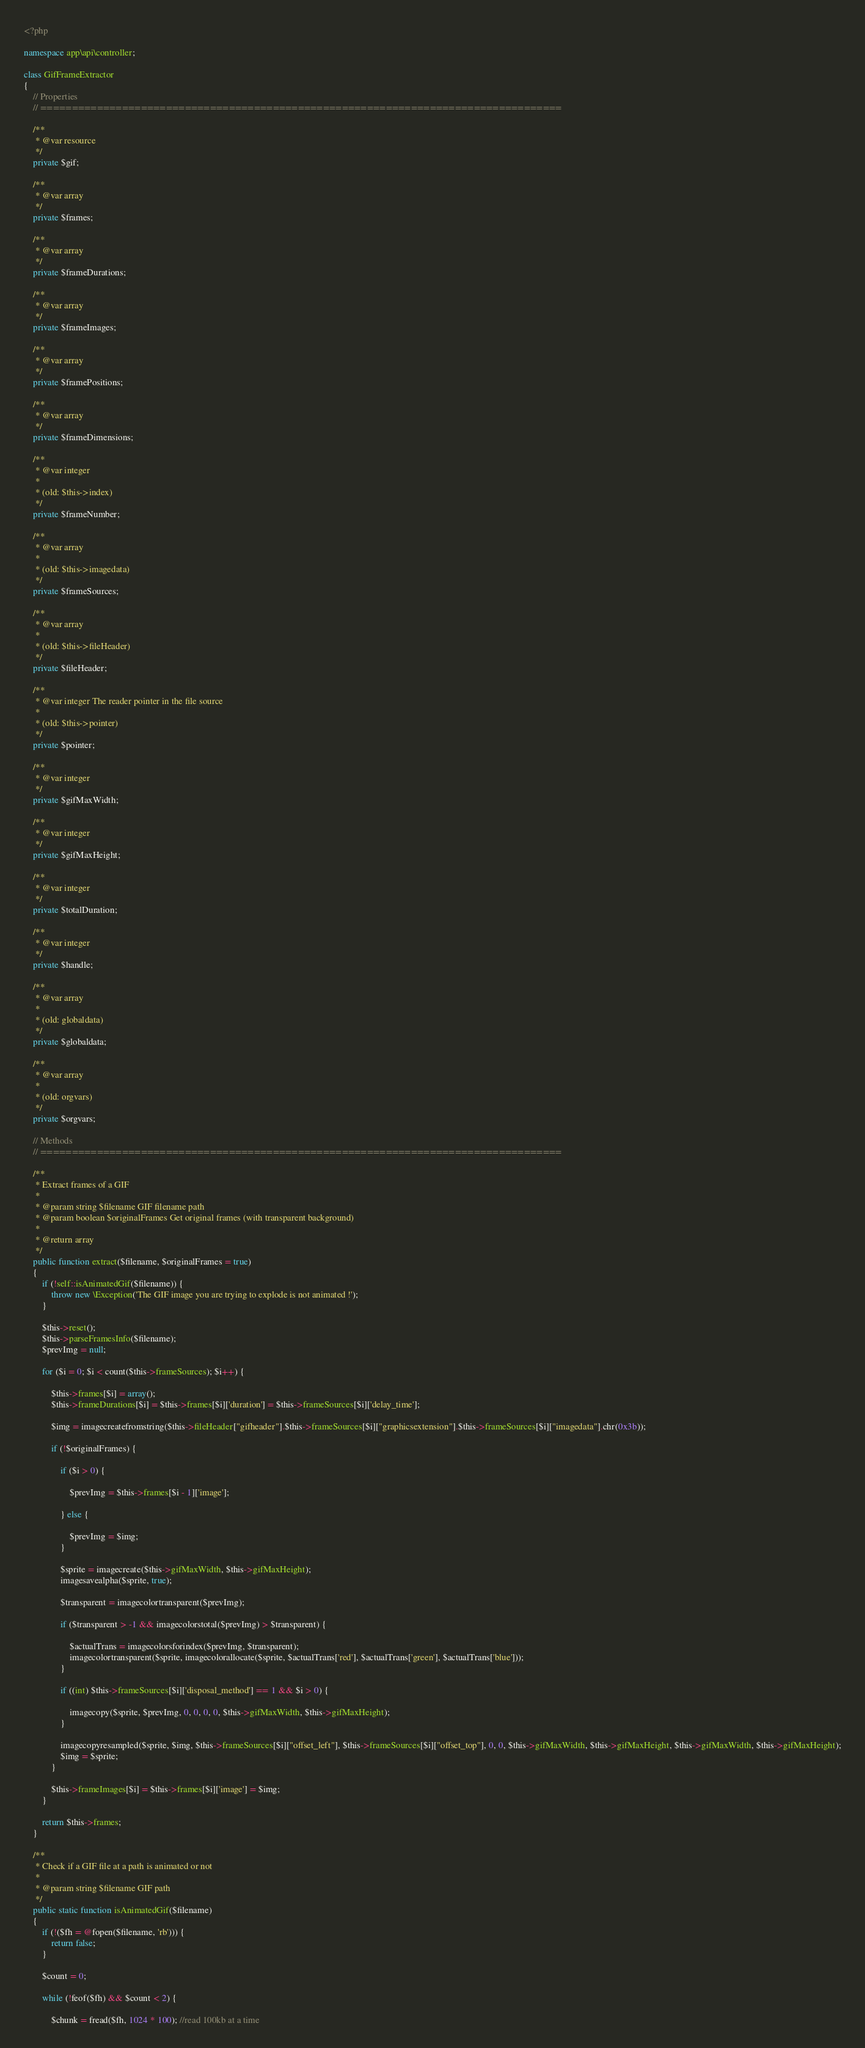<code> <loc_0><loc_0><loc_500><loc_500><_PHP_><?php

namespace app\api\controller;

class GifFrameExtractor
{
    // Properties
    // ===================================================================================

    /**
     * @var resource
     */
    private $gif;

    /**
     * @var array
     */
    private $frames;

    /**
     * @var array
     */
    private $frameDurations;

    /**
     * @var array
     */
    private $frameImages;

    /**
     * @var array
     */
    private $framePositions;

    /**
     * @var array
     */
    private $frameDimensions;

    /**
     * @var integer
     *
     * (old: $this->index)
     */
    private $frameNumber;

    /**
     * @var array
     *
     * (old: $this->imagedata)
     */
    private $frameSources;

    /**
     * @var array
     *
     * (old: $this->fileHeader)
     */
    private $fileHeader;

    /**
     * @var integer The reader pointer in the file source
     *
     * (old: $this->pointer)
     */
    private $pointer;

    /**
     * @var integer
     */
    private $gifMaxWidth;

    /**
     * @var integer
     */
    private $gifMaxHeight;

    /**
     * @var integer
     */
    private $totalDuration;

    /**
     * @var integer
     */
    private $handle;

    /**
     * @var array
     *
     * (old: globaldata)
     */
    private $globaldata;

    /**
     * @var array
     *
     * (old: orgvars)
     */
    private $orgvars;

    // Methods
    // ===================================================================================

    /**
     * Extract frames of a GIF
     *
     * @param string $filename GIF filename path
     * @param boolean $originalFrames Get original frames (with transparent background)
     *
     * @return array
     */
    public function extract($filename, $originalFrames = true)
    {
        if (!self::isAnimatedGif($filename)) {
            throw new \Exception('The GIF image you are trying to explode is not animated !');
        }

        $this->reset();
        $this->parseFramesInfo($filename);
        $prevImg = null;

        for ($i = 0; $i < count($this->frameSources); $i++) {

            $this->frames[$i] = array();
            $this->frameDurations[$i] = $this->frames[$i]['duration'] = $this->frameSources[$i]['delay_time'];

            $img = imagecreatefromstring($this->fileHeader["gifheader"].$this->frameSources[$i]["graphicsextension"].$this->frameSources[$i]["imagedata"].chr(0x3b));

            if (!$originalFrames) {

                if ($i > 0) {

                    $prevImg = $this->frames[$i - 1]['image'];

                } else {

                    $prevImg = $img;
                }

                $sprite = imagecreate($this->gifMaxWidth, $this->gifMaxHeight);
                imagesavealpha($sprite, true);

                $transparent = imagecolortransparent($prevImg);

                if ($transparent > -1 && imagecolorstotal($prevImg) > $transparent) {

                    $actualTrans = imagecolorsforindex($prevImg, $transparent);
                    imagecolortransparent($sprite, imagecolorallocate($sprite, $actualTrans['red'], $actualTrans['green'], $actualTrans['blue']));
                }

                if ((int) $this->frameSources[$i]['disposal_method'] == 1 && $i > 0) {

                    imagecopy($sprite, $prevImg, 0, 0, 0, 0, $this->gifMaxWidth, $this->gifMaxHeight);
                }

                imagecopyresampled($sprite, $img, $this->frameSources[$i]["offset_left"], $this->frameSources[$i]["offset_top"], 0, 0, $this->gifMaxWidth, $this->gifMaxHeight, $this->gifMaxWidth, $this->gifMaxHeight);
                $img = $sprite;
            }

            $this->frameImages[$i] = $this->frames[$i]['image'] = $img;
        }

        return $this->frames;
    }

    /**
     * Check if a GIF file at a path is animated or not
     *
     * @param string $filename GIF path
     */
    public static function isAnimatedGif($filename)
    {
        if (!($fh = @fopen($filename, 'rb'))) {
            return false;
        }

        $count = 0;

        while (!feof($fh) && $count < 2) {

            $chunk = fread($fh, 1024 * 100); //read 100kb at a time</code> 